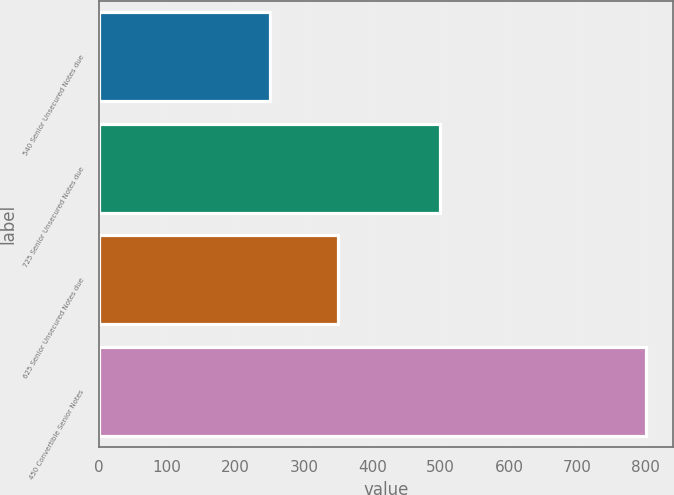Convert chart to OTSL. <chart><loc_0><loc_0><loc_500><loc_500><bar_chart><fcel>540 Senior Unsecured Notes due<fcel>725 Senior Unsecured Notes due<fcel>625 Senior Unsecured Notes due<fcel>450 Convertible Senior Notes<nl><fcel>249.7<fcel>499.2<fcel>350.3<fcel>800<nl></chart> 